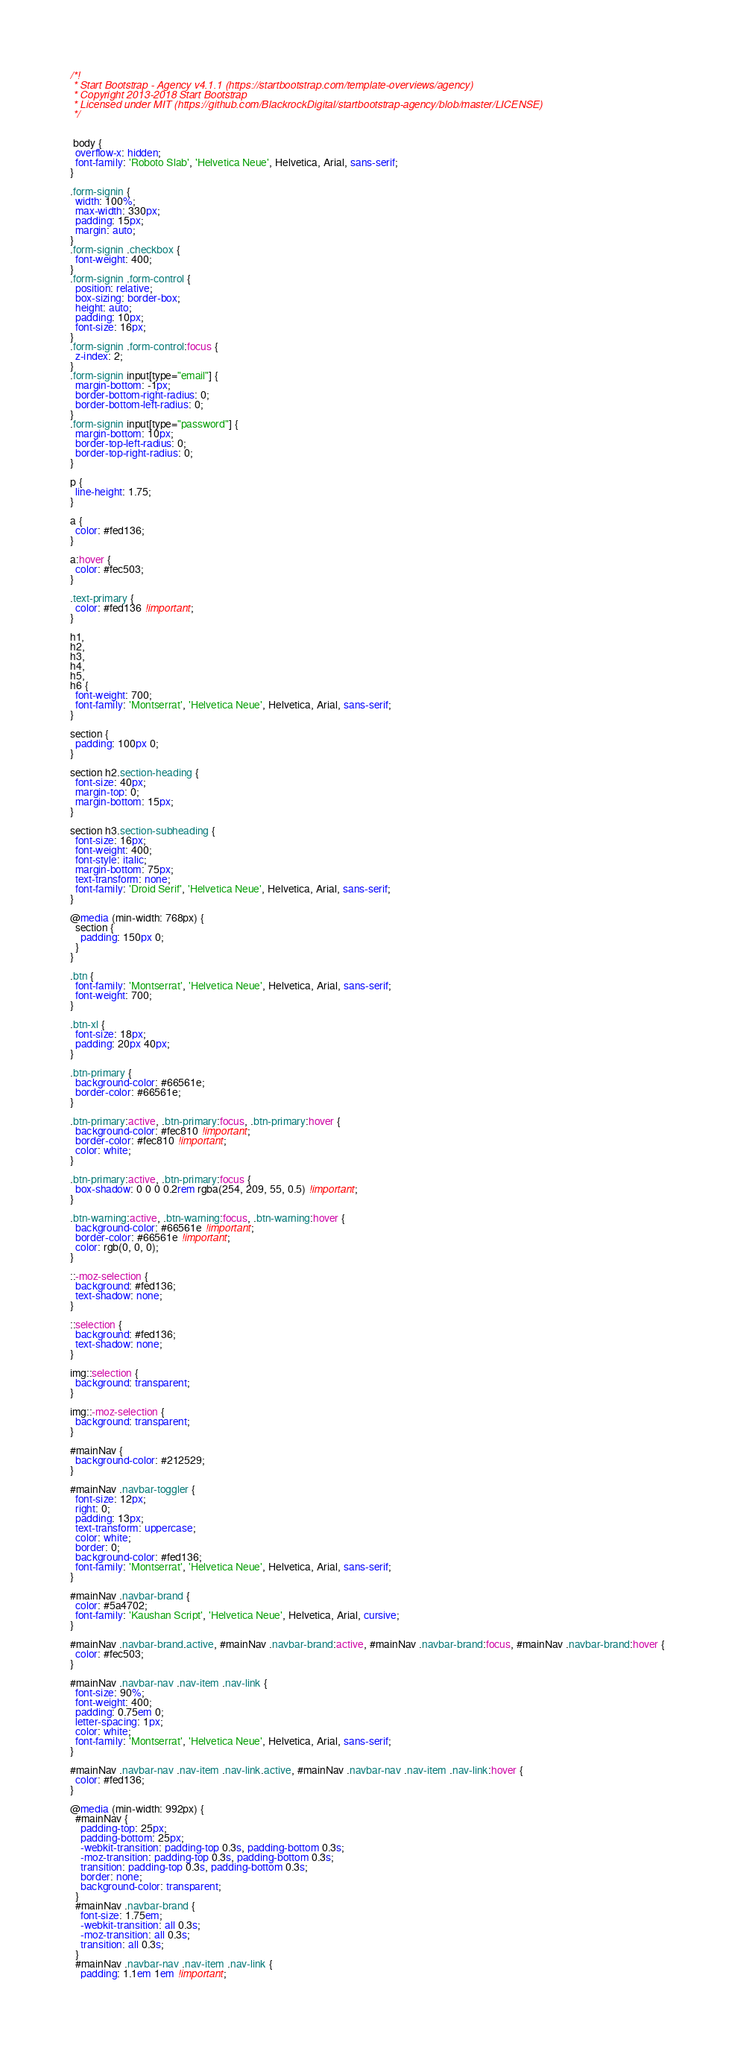<code> <loc_0><loc_0><loc_500><loc_500><_CSS_>/*!
 * Start Bootstrap - Agency v4.1.1 (https://startbootstrap.com/template-overviews/agency)
 * Copyright 2013-2018 Start Bootstrap
 * Licensed under MIT (https://github.com/BlackrockDigital/startbootstrap-agency/blob/master/LICENSE)
 */


 body {
  overflow-x: hidden;
  font-family: 'Roboto Slab', 'Helvetica Neue', Helvetica, Arial, sans-serif;
}

.form-signin {
  width: 100%;
  max-width: 330px;
  padding: 15px;
  margin: auto;
}
.form-signin .checkbox {
  font-weight: 400;
}
.form-signin .form-control {
  position: relative;
  box-sizing: border-box;
  height: auto;
  padding: 10px;
  font-size: 16px;
}
.form-signin .form-control:focus {
  z-index: 2;
}
.form-signin input[type="email"] {
  margin-bottom: -1px;
  border-bottom-right-radius: 0;
  border-bottom-left-radius: 0;
}
.form-signin input[type="password"] {
  margin-bottom: 10px;
  border-top-left-radius: 0;
  border-top-right-radius: 0;
}

p {
  line-height: 1.75;
}

a {
  color: #fed136;
}

a:hover {
  color: #fec503;
}

.text-primary {
  color: #fed136 !important;
}

h1,
h2,
h3,
h4,
h5,
h6 {
  font-weight: 700;
  font-family: 'Montserrat', 'Helvetica Neue', Helvetica, Arial, sans-serif;
}

section {
  padding: 100px 0;
}

section h2.section-heading {
  font-size: 40px;
  margin-top: 0;
  margin-bottom: 15px;
}

section h3.section-subheading {
  font-size: 16px;
  font-weight: 400;
  font-style: italic;
  margin-bottom: 75px;
  text-transform: none;
  font-family: 'Droid Serif', 'Helvetica Neue', Helvetica, Arial, sans-serif;
}

@media (min-width: 768px) {
  section {
    padding: 150px 0;
  }
}

.btn {
  font-family: 'Montserrat', 'Helvetica Neue', Helvetica, Arial, sans-serif;
  font-weight: 700;
}

.btn-xl {
  font-size: 18px;
  padding: 20px 40px;
}

.btn-primary {
  background-color: #66561e;
  border-color: #66561e;
}

.btn-primary:active, .btn-primary:focus, .btn-primary:hover {
  background-color: #fec810 !important;
  border-color: #fec810 !important;
  color: white;
}

.btn-primary:active, .btn-primary:focus {
  box-shadow: 0 0 0 0.2rem rgba(254, 209, 55, 0.5) !important;
}

.btn-warning:active, .btn-warning:focus, .btn-warning:hover {
  background-color: #66561e !important;
  border-color: #66561e !important;
  color: rgb(0, 0, 0);
}

::-moz-selection {
  background: #fed136;
  text-shadow: none;
}

::selection {
  background: #fed136;
  text-shadow: none;
}

img::selection {
  background: transparent;
}

img::-moz-selection {
  background: transparent;
}

#mainNav {
  background-color: #212529;
}

#mainNav .navbar-toggler {
  font-size: 12px;
  right: 0;
  padding: 13px;
  text-transform: uppercase;
  color: white;
  border: 0;
  background-color: #fed136;
  font-family: 'Montserrat', 'Helvetica Neue', Helvetica, Arial, sans-serif;
}

#mainNav .navbar-brand {
  color: #5a4702;
  font-family: 'Kaushan Script', 'Helvetica Neue', Helvetica, Arial, cursive;
}

#mainNav .navbar-brand.active, #mainNav .navbar-brand:active, #mainNav .navbar-brand:focus, #mainNav .navbar-brand:hover {
  color: #fec503;
}

#mainNav .navbar-nav .nav-item .nav-link {
  font-size: 90%;
  font-weight: 400;
  padding: 0.75em 0;
  letter-spacing: 1px;
  color: white;
  font-family: 'Montserrat', 'Helvetica Neue', Helvetica, Arial, sans-serif;
}

#mainNav .navbar-nav .nav-item .nav-link.active, #mainNav .navbar-nav .nav-item .nav-link:hover {
  color: #fed136;
}

@media (min-width: 992px) {
  #mainNav {
    padding-top: 25px;
    padding-bottom: 25px;
    -webkit-transition: padding-top 0.3s, padding-bottom 0.3s;
    -moz-transition: padding-top 0.3s, padding-bottom 0.3s;
    transition: padding-top 0.3s, padding-bottom 0.3s;
    border: none;
    background-color: transparent;
  }
  #mainNav .navbar-brand {
    font-size: 1.75em;
    -webkit-transition: all 0.3s;
    -moz-transition: all 0.3s;
    transition: all 0.3s;
  }
  #mainNav .navbar-nav .nav-item .nav-link {
    padding: 1.1em 1em !important;</code> 